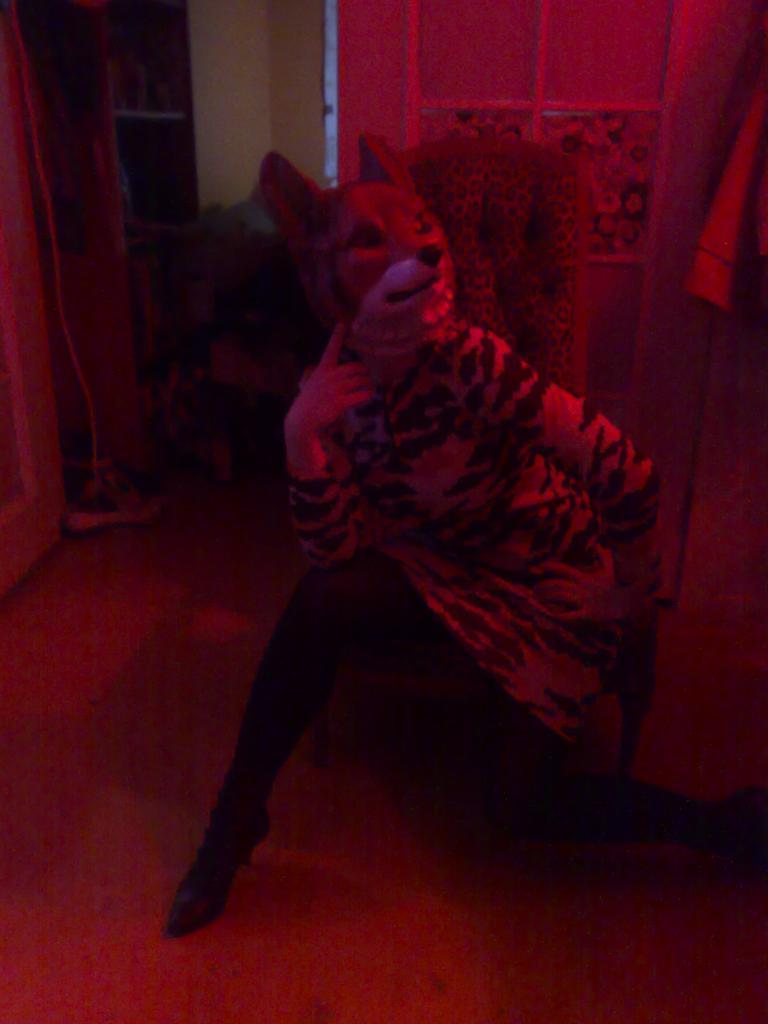Could you give a brief overview of what you see in this image? In this image there is a person with a mask , and in the background there is a chair and some other items. 